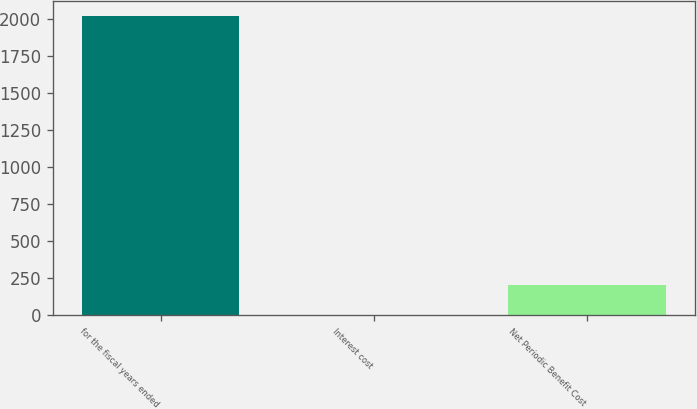Convert chart to OTSL. <chart><loc_0><loc_0><loc_500><loc_500><bar_chart><fcel>for the fiscal years ended<fcel>Interest cost<fcel>Net Periodic Benefit Cost<nl><fcel>2015<fcel>0.2<fcel>201.68<nl></chart> 